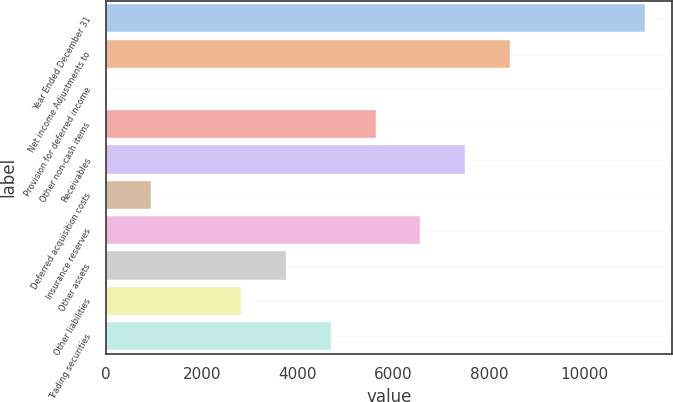<chart> <loc_0><loc_0><loc_500><loc_500><bar_chart><fcel>Year Ended December 31<fcel>Net income Adjustments to<fcel>Provision for deferred income<fcel>Other non-cash items<fcel>Receivables<fcel>Deferred acquisition costs<fcel>Insurance reserves<fcel>Other assets<fcel>Other liabilities<fcel>Trading securities<nl><fcel>11255<fcel>8444<fcel>11<fcel>5633<fcel>7507<fcel>948<fcel>6570<fcel>3759<fcel>2822<fcel>4696<nl></chart> 